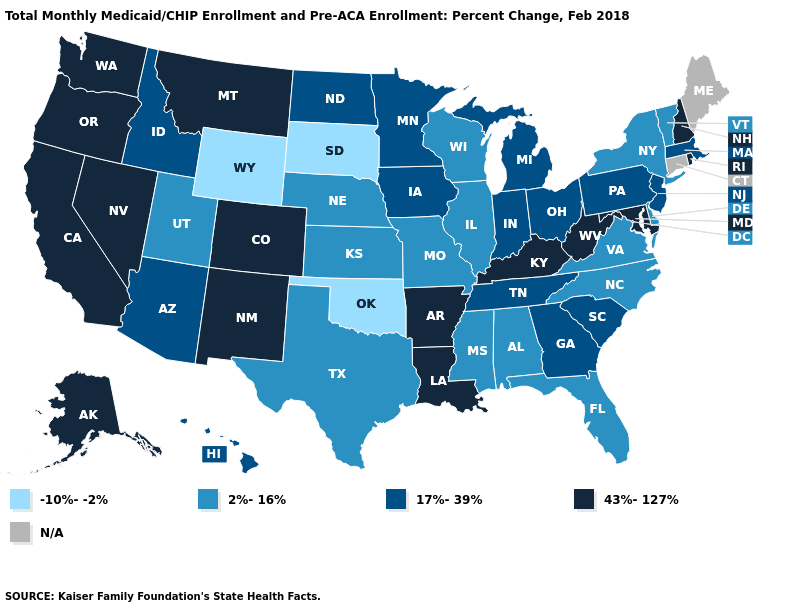Does Idaho have the lowest value in the USA?
Concise answer only. No. Does Rhode Island have the highest value in the USA?
Answer briefly. Yes. Name the states that have a value in the range -10%--2%?
Short answer required. Oklahoma, South Dakota, Wyoming. Does Louisiana have the highest value in the USA?
Answer briefly. Yes. Name the states that have a value in the range 2%-16%?
Concise answer only. Alabama, Delaware, Florida, Illinois, Kansas, Mississippi, Missouri, Nebraska, New York, North Carolina, Texas, Utah, Vermont, Virginia, Wisconsin. What is the highest value in the USA?
Quick response, please. 43%-127%. What is the value of New Jersey?
Short answer required. 17%-39%. Does Wisconsin have the lowest value in the USA?
Short answer required. No. What is the value of Louisiana?
Concise answer only. 43%-127%. What is the lowest value in states that border South Dakota?
Give a very brief answer. -10%--2%. Among the states that border New York , does New Jersey have the highest value?
Quick response, please. Yes. Does Rhode Island have the highest value in the Northeast?
Quick response, please. Yes. Which states hav the highest value in the MidWest?
Be succinct. Indiana, Iowa, Michigan, Minnesota, North Dakota, Ohio. Among the states that border West Virginia , does Maryland have the highest value?
Write a very short answer. Yes. What is the value of Florida?
Concise answer only. 2%-16%. 